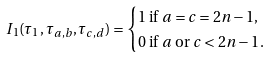Convert formula to latex. <formula><loc_0><loc_0><loc_500><loc_500>I _ { 1 } ( \tau _ { 1 } , \tau _ { a , b } , \tau _ { c , d } ) & = \begin{cases} 1 \text { if $a=c=2n-1$,} \\ 0 \text { if $a$ or $c<2n-1$} . \end{cases}</formula> 